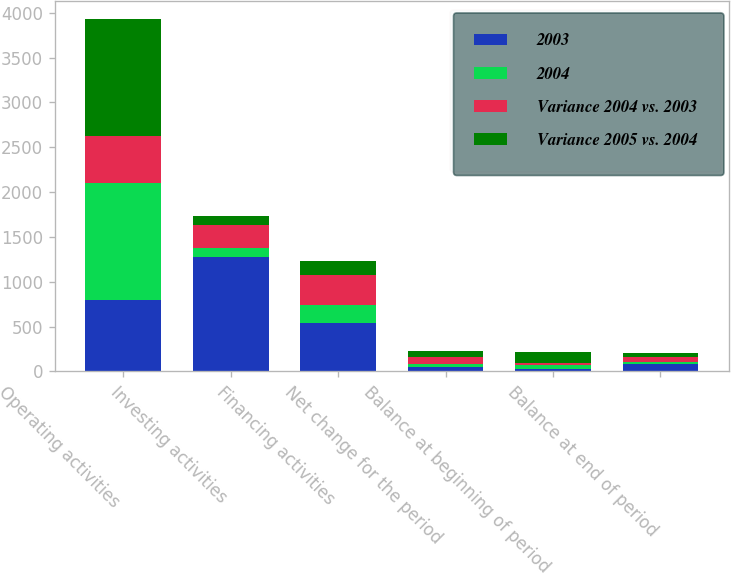Convert chart. <chart><loc_0><loc_0><loc_500><loc_500><stacked_bar_chart><ecel><fcel>Operating activities<fcel>Investing activities<fcel>Financing activities<fcel>Net change for the period<fcel>Balance at beginning of period<fcel>Balance at end of period<nl><fcel>2003<fcel>793<fcel>1277<fcel>539<fcel>55<fcel>26<fcel>81<nl><fcel>2004<fcel>1311<fcel>99.5<fcel>197<fcel>23<fcel>49<fcel>26<nl><fcel>Variance 2004 vs. 2003<fcel>518<fcel>254<fcel>342<fcel>78<fcel>23<fcel>55<nl><fcel>Variance 2005 vs. 2004<fcel>1309<fcel>99.5<fcel>156<fcel>69<fcel>118<fcel>49<nl></chart> 